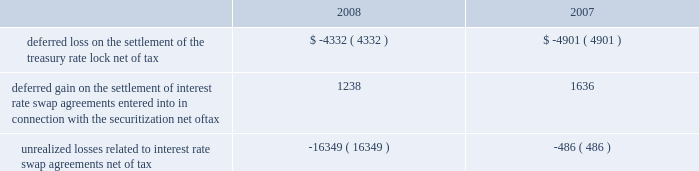American tower corporation and subsidiaries notes to consolidated financial statements 2014 ( continued ) of certain of its assets and liabilities under its interest rate swap agreements held as of december 31 , 2006 and entered into during the first half of 2007 .
In addition , the company paid $ 8.0 million related to a treasury rate lock agreement entered into and settled during the year ended december 31 , 2008 .
The cost of the treasury rate lock is being recognized as additional interest expense over the 10-year term of the 7.00% ( 7.00 % ) notes .
During the year ended december 31 , 2007 , the company also received $ 3.1 million in cash upon settlement of the assets and liabilities under ten forward starting interest rate swap agreements with an aggregate notional amount of $ 1.4 billion , which were designated as cash flow hedges to manage exposure to variability in cash flows relating to forecasted interest payments in connection with the certificates issued in the securitization in may 2007 .
The settlement is being recognized as a reduction in interest expense over the five-year period for which the interest rate swaps were designated as hedges .
The company also received $ 17.0 million in cash upon settlement of the assets and liabilities under thirteen additional interest rate swap agreements with an aggregate notional amount of $ 850.0 million that managed exposure to variability of interest rates under the credit facilities but were not considered cash flow hedges for accounting purposes .
This gain is included in other income in the accompanying consolidated statement of operations for the year ended december 31 , 2007 .
As of december 31 , 2008 and 2007 , other comprehensive ( loss ) income included the following items related to derivative financial instruments ( in thousands ) : .
During the years ended december 31 , 2008 and 2007 , the company recorded an aggregate net unrealized loss of approximately $ 15.8 million and $ 3.2 million , respectively ( net of a tax provision of approximately $ 10.2 million and $ 2.0 million , respectively ) in other comprehensive loss for the change in fair value of interest rate swaps designated as cash flow hedges and reclassified an aggregate of $ 0.1 million and $ 6.2 million , respectively ( net of an income tax provision of $ 2.0 million and an income tax benefit of $ 3.3 million , respectively ) into results of operations .
Fair valuemeasurements the company determines the fair market values of its financial instruments based on the fair value hierarchy established in sfas no .
157 , which requires an entity to maximize the use of observable inputs and minimize the use of unobservable inputs when measuring fair value .
The standard describes three levels of inputs that may be used to measure fair value .
Level 1 quoted prices in active markets for identical assets or liabilities that the company has the ability to access at the measurement date .
The company 2019s level 1 assets consist of available-for-sale securities traded on active markets as well as certain brazilian treasury securities that are highly liquid and are actively traded in over-the-counter markets .
Level 2 observable inputs other than level 1 prices , such as quoted prices for similar assets or liabilities ; quoted prices in markets that are not active ; or other inputs that are observable or can be corroborated by observable market data for substantially the full term of the assets or liabilities. .
What is the pre-tax aggregate net unrealized loss in 2008? 
Computations: (15.8 + 10.2)
Answer: 26.0. American tower corporation and subsidiaries notes to consolidated financial statements 2014 ( continued ) of certain of its assets and liabilities under its interest rate swap agreements held as of december 31 , 2006 and entered into during the first half of 2007 .
In addition , the company paid $ 8.0 million related to a treasury rate lock agreement entered into and settled during the year ended december 31 , 2008 .
The cost of the treasury rate lock is being recognized as additional interest expense over the 10-year term of the 7.00% ( 7.00 % ) notes .
During the year ended december 31 , 2007 , the company also received $ 3.1 million in cash upon settlement of the assets and liabilities under ten forward starting interest rate swap agreements with an aggregate notional amount of $ 1.4 billion , which were designated as cash flow hedges to manage exposure to variability in cash flows relating to forecasted interest payments in connection with the certificates issued in the securitization in may 2007 .
The settlement is being recognized as a reduction in interest expense over the five-year period for which the interest rate swaps were designated as hedges .
The company also received $ 17.0 million in cash upon settlement of the assets and liabilities under thirteen additional interest rate swap agreements with an aggregate notional amount of $ 850.0 million that managed exposure to variability of interest rates under the credit facilities but were not considered cash flow hedges for accounting purposes .
This gain is included in other income in the accompanying consolidated statement of operations for the year ended december 31 , 2007 .
As of december 31 , 2008 and 2007 , other comprehensive ( loss ) income included the following items related to derivative financial instruments ( in thousands ) : .
During the years ended december 31 , 2008 and 2007 , the company recorded an aggregate net unrealized loss of approximately $ 15.8 million and $ 3.2 million , respectively ( net of a tax provision of approximately $ 10.2 million and $ 2.0 million , respectively ) in other comprehensive loss for the change in fair value of interest rate swaps designated as cash flow hedges and reclassified an aggregate of $ 0.1 million and $ 6.2 million , respectively ( net of an income tax provision of $ 2.0 million and an income tax benefit of $ 3.3 million , respectively ) into results of operations .
Fair valuemeasurements the company determines the fair market values of its financial instruments based on the fair value hierarchy established in sfas no .
157 , which requires an entity to maximize the use of observable inputs and minimize the use of unobservable inputs when measuring fair value .
The standard describes three levels of inputs that may be used to measure fair value .
Level 1 quoted prices in active markets for identical assets or liabilities that the company has the ability to access at the measurement date .
The company 2019s level 1 assets consist of available-for-sale securities traded on active markets as well as certain brazilian treasury securities that are highly liquid and are actively traded in over-the-counter markets .
Level 2 observable inputs other than level 1 prices , such as quoted prices for similar assets or liabilities ; quoted prices in markets that are not active ; or other inputs that are observable or can be corroborated by observable market data for substantially the full term of the assets or liabilities. .
In 2008 what was the approximate tax rate on the company recorded an aggregate net unrealized loss? 
Computations: ((15.8 - 10.2) / 10.2)
Answer: 0.54902. 